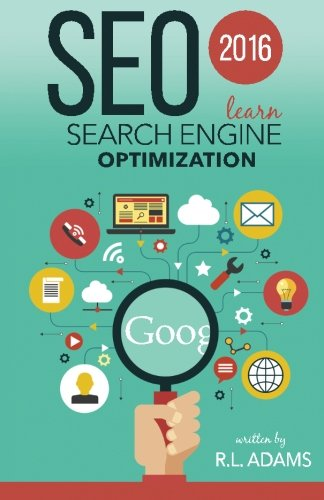Is this a digital technology book? Yes, this book falls under the category of digital technology as it addresses topics related to search engine optimization and online marketing strategies. 